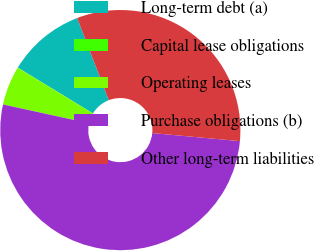<chart> <loc_0><loc_0><loc_500><loc_500><pie_chart><fcel>Long-term debt (a)<fcel>Capital lease obligations<fcel>Operating leases<fcel>Purchase obligations (b)<fcel>Other long-term liabilities<nl><fcel>10.43%<fcel>0.05%<fcel>5.24%<fcel>51.96%<fcel>32.32%<nl></chart> 